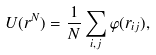<formula> <loc_0><loc_0><loc_500><loc_500>U ( { r } ^ { N } ) = \frac { 1 } { N } \sum _ { i , j } \varphi ( r _ { i j } ) ,</formula> 